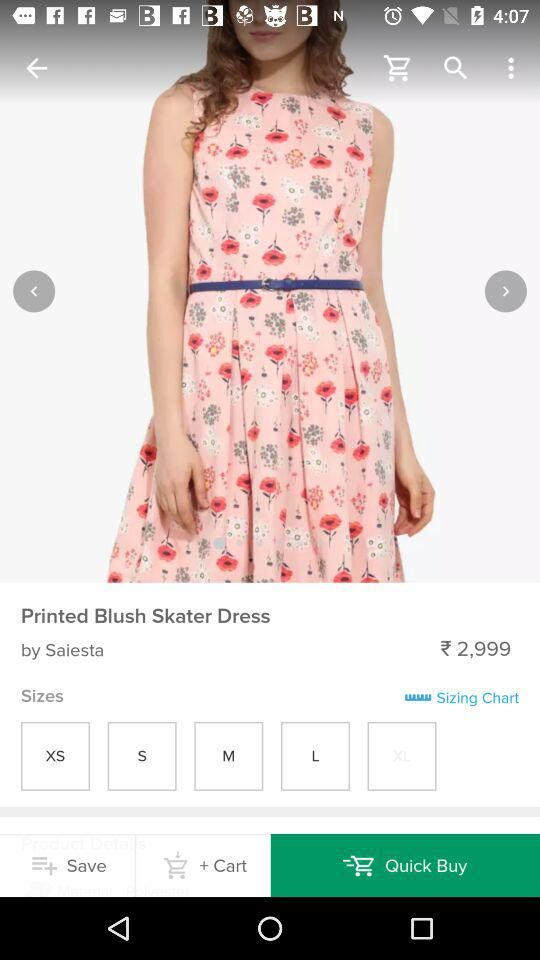What is the price of this dress? The price of this dress is ₹ 2,999. 